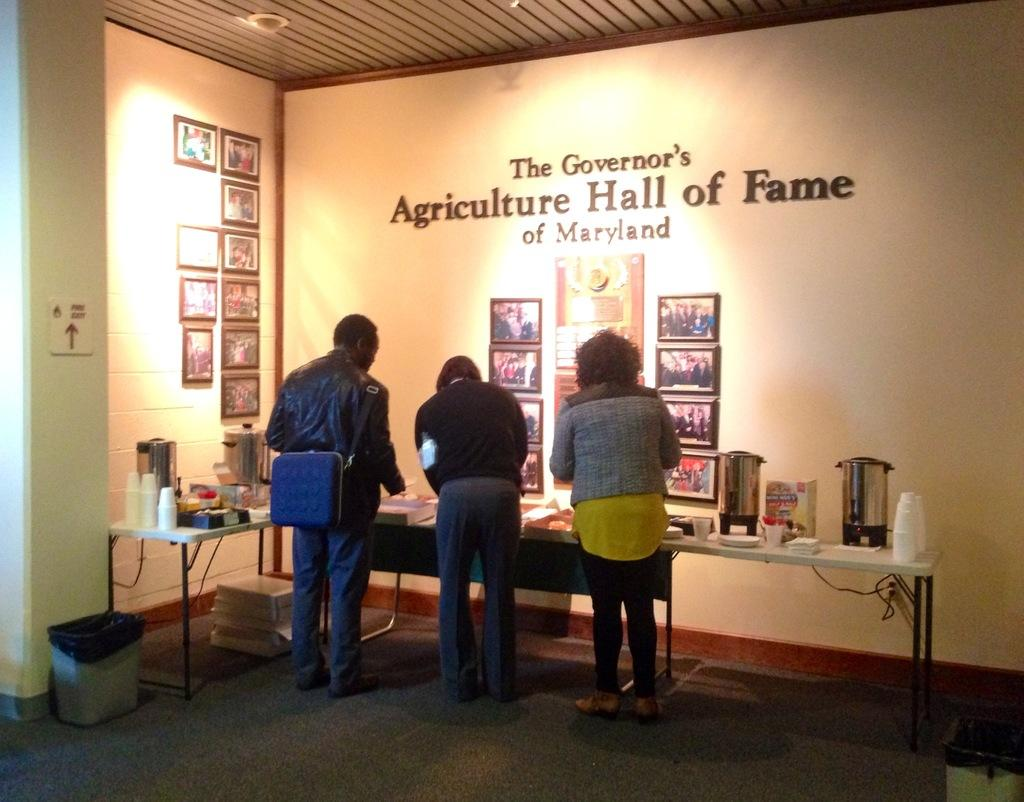<image>
Present a compact description of the photo's key features. People gather around a refreshments table at the Agriculture Hall of Fame. 